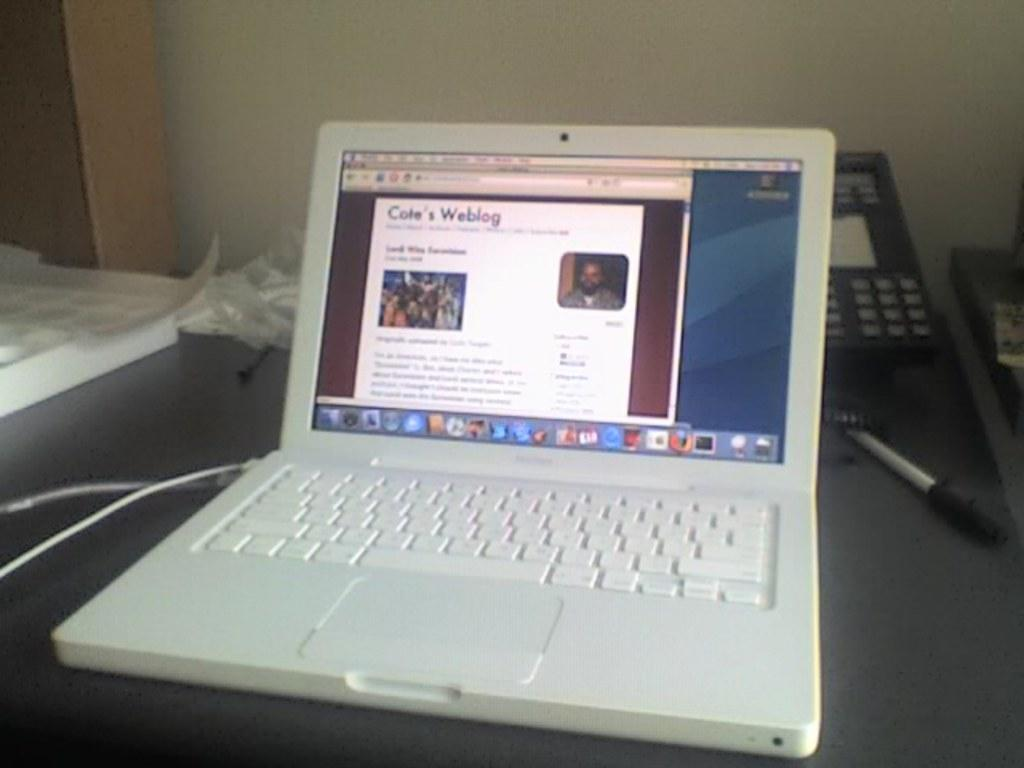<image>
Create a compact narrative representing the image presented. A white laptop is displaying Cate's Weblog on the screen. 